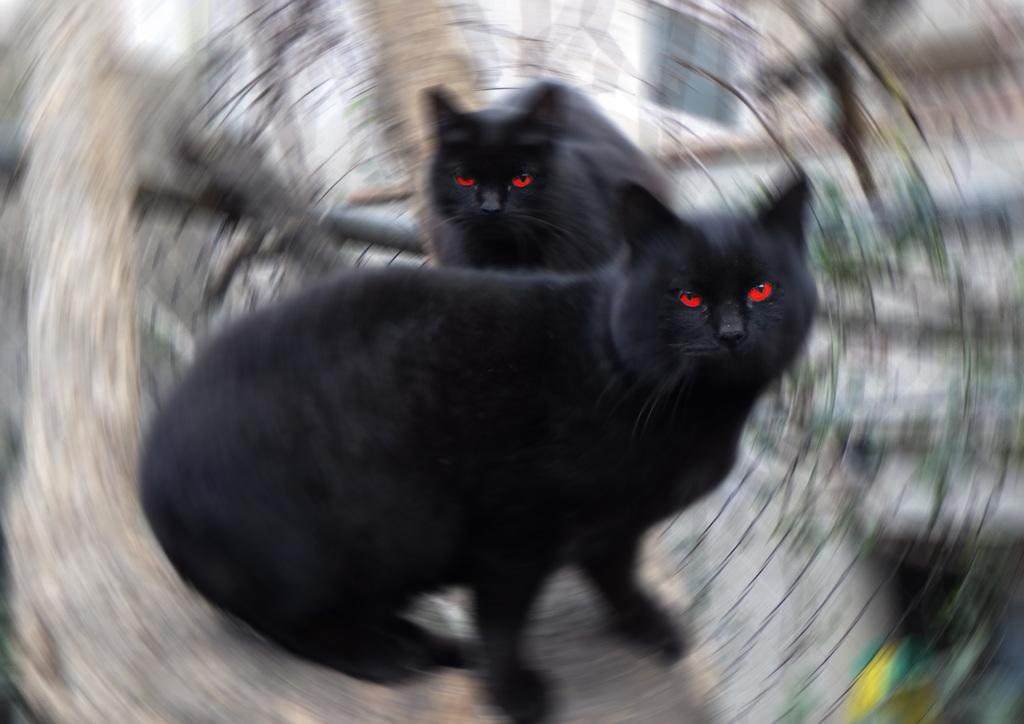How many cats are in the image? There are two black color cats in the image. Can you describe the background of the image? The background of the image is blurred. What time of day is it in the image, given that it's morning? The provided facts do not mention the time of day, so we cannot determine if it's morning or not. 